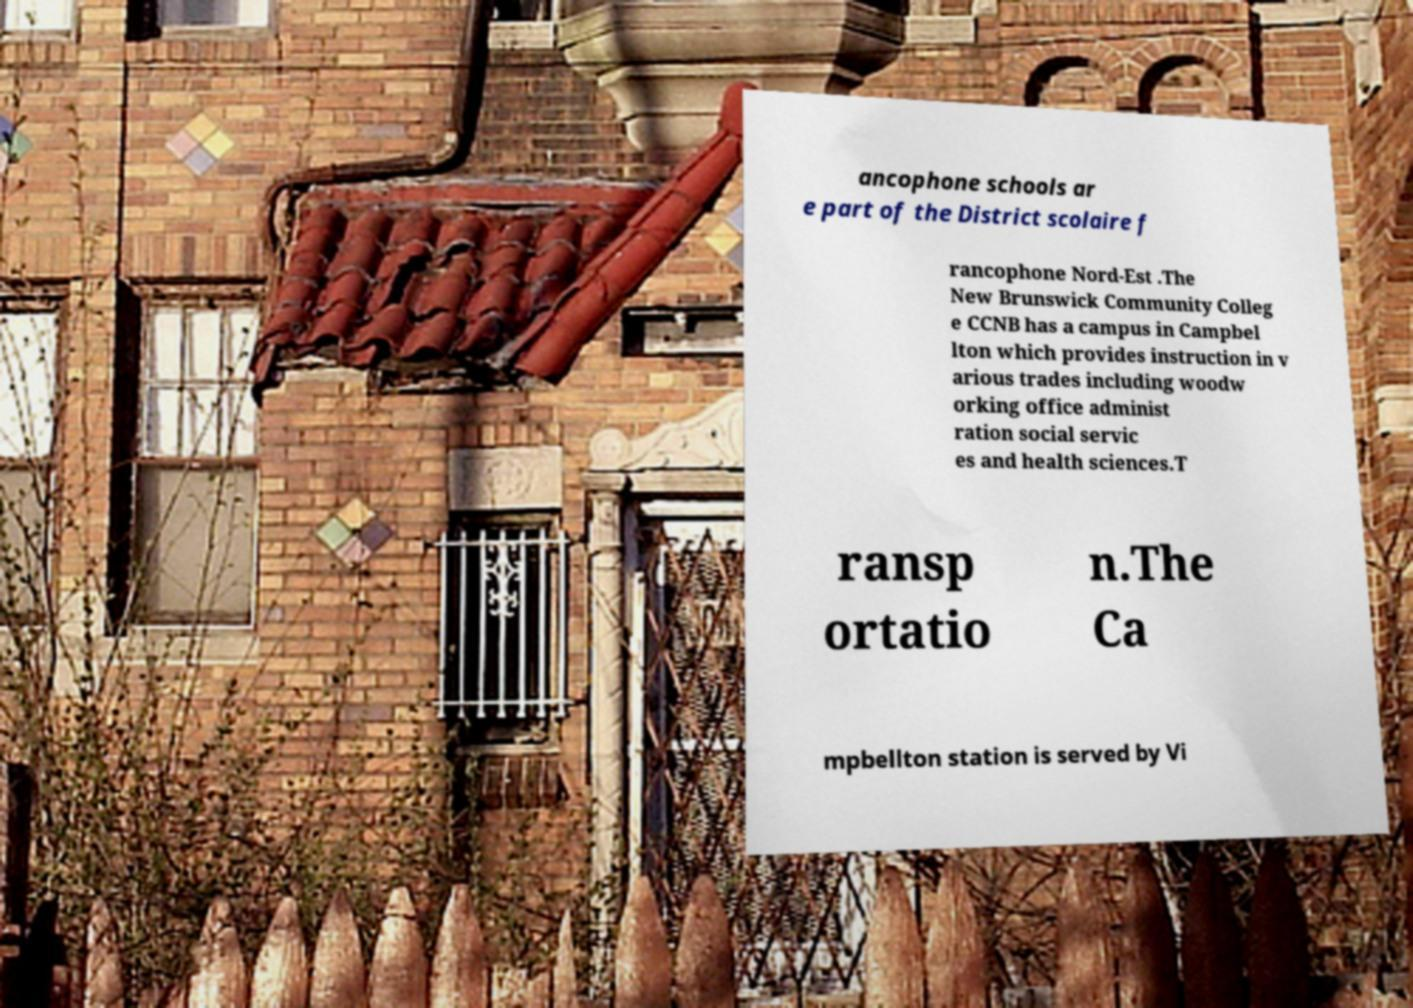Can you read and provide the text displayed in the image?This photo seems to have some interesting text. Can you extract and type it out for me? ancophone schools ar e part of the District scolaire f rancophone Nord-Est .The New Brunswick Community Colleg e CCNB has a campus in Campbel lton which provides instruction in v arious trades including woodw orking office administ ration social servic es and health sciences.T ransp ortatio n.The Ca mpbellton station is served by Vi 